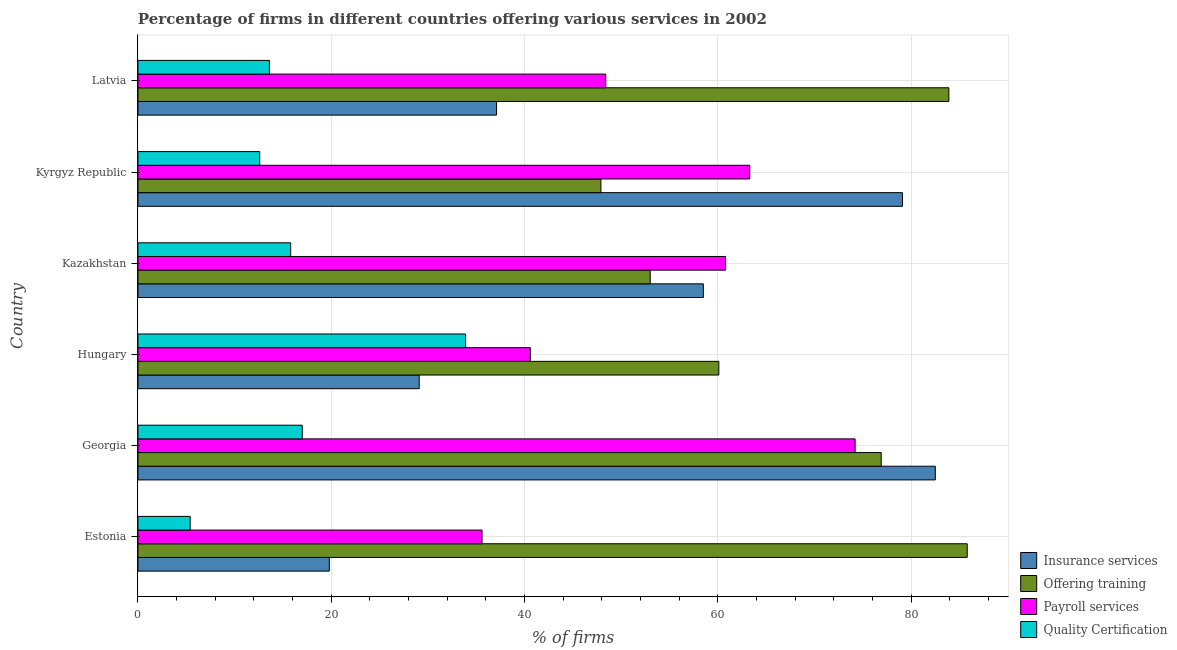How many bars are there on the 2nd tick from the bottom?
Ensure brevity in your answer.  4. What is the label of the 1st group of bars from the top?
Your answer should be compact. Latvia. What is the percentage of firms offering quality certification in Kyrgyz Republic?
Provide a succinct answer. 12.6. Across all countries, what is the maximum percentage of firms offering training?
Ensure brevity in your answer.  85.8. In which country was the percentage of firms offering payroll services maximum?
Keep it short and to the point. Georgia. In which country was the percentage of firms offering payroll services minimum?
Offer a very short reply. Estonia. What is the total percentage of firms offering training in the graph?
Keep it short and to the point. 407.6. What is the difference between the percentage of firms offering payroll services in Georgia and that in Latvia?
Keep it short and to the point. 25.8. What is the difference between the percentage of firms offering training in Hungary and the percentage of firms offering quality certification in Kazakhstan?
Provide a succinct answer. 44.3. What is the average percentage of firms offering payroll services per country?
Provide a succinct answer. 53.82. What is the ratio of the percentage of firms offering payroll services in Hungary to that in Latvia?
Make the answer very short. 0.84. Is the percentage of firms offering quality certification in Georgia less than that in Kazakhstan?
Provide a succinct answer. No. Is the difference between the percentage of firms offering quality certification in Estonia and Kyrgyz Republic greater than the difference between the percentage of firms offering training in Estonia and Kyrgyz Republic?
Your answer should be very brief. No. What is the difference between the highest and the lowest percentage of firms offering payroll services?
Offer a very short reply. 38.6. In how many countries, is the percentage of firms offering insurance services greater than the average percentage of firms offering insurance services taken over all countries?
Your answer should be compact. 3. Is the sum of the percentage of firms offering quality certification in Georgia and Hungary greater than the maximum percentage of firms offering training across all countries?
Make the answer very short. No. What does the 1st bar from the top in Kazakhstan represents?
Your answer should be very brief. Quality Certification. What does the 2nd bar from the bottom in Hungary represents?
Offer a very short reply. Offering training. How many bars are there?
Your answer should be very brief. 24. Are all the bars in the graph horizontal?
Your response must be concise. Yes. Are the values on the major ticks of X-axis written in scientific E-notation?
Offer a very short reply. No. Does the graph contain any zero values?
Your answer should be very brief. No. Does the graph contain grids?
Offer a terse response. Yes. What is the title of the graph?
Offer a terse response. Percentage of firms in different countries offering various services in 2002. Does "Debt policy" appear as one of the legend labels in the graph?
Offer a terse response. No. What is the label or title of the X-axis?
Give a very brief answer. % of firms. What is the % of firms in Insurance services in Estonia?
Provide a short and direct response. 19.8. What is the % of firms in Offering training in Estonia?
Offer a terse response. 85.8. What is the % of firms in Payroll services in Estonia?
Provide a succinct answer. 35.6. What is the % of firms in Insurance services in Georgia?
Give a very brief answer. 82.5. What is the % of firms of Offering training in Georgia?
Your response must be concise. 76.9. What is the % of firms of Payroll services in Georgia?
Offer a terse response. 74.2. What is the % of firms in Insurance services in Hungary?
Ensure brevity in your answer.  29.1. What is the % of firms of Offering training in Hungary?
Offer a very short reply. 60.1. What is the % of firms in Payroll services in Hungary?
Ensure brevity in your answer.  40.6. What is the % of firms in Quality Certification in Hungary?
Offer a very short reply. 33.9. What is the % of firms in Insurance services in Kazakhstan?
Your answer should be compact. 58.5. What is the % of firms in Offering training in Kazakhstan?
Your response must be concise. 53. What is the % of firms in Payroll services in Kazakhstan?
Your answer should be compact. 60.8. What is the % of firms in Insurance services in Kyrgyz Republic?
Ensure brevity in your answer.  79.1. What is the % of firms in Offering training in Kyrgyz Republic?
Offer a terse response. 47.9. What is the % of firms of Payroll services in Kyrgyz Republic?
Your answer should be compact. 63.3. What is the % of firms in Quality Certification in Kyrgyz Republic?
Provide a short and direct response. 12.6. What is the % of firms of Insurance services in Latvia?
Your response must be concise. 37.1. What is the % of firms in Offering training in Latvia?
Your response must be concise. 83.9. What is the % of firms of Payroll services in Latvia?
Give a very brief answer. 48.4. What is the % of firms of Quality Certification in Latvia?
Give a very brief answer. 13.6. Across all countries, what is the maximum % of firms of Insurance services?
Your response must be concise. 82.5. Across all countries, what is the maximum % of firms of Offering training?
Provide a short and direct response. 85.8. Across all countries, what is the maximum % of firms in Payroll services?
Provide a short and direct response. 74.2. Across all countries, what is the maximum % of firms of Quality Certification?
Provide a succinct answer. 33.9. Across all countries, what is the minimum % of firms in Insurance services?
Provide a succinct answer. 19.8. Across all countries, what is the minimum % of firms of Offering training?
Your answer should be very brief. 47.9. Across all countries, what is the minimum % of firms in Payroll services?
Offer a terse response. 35.6. What is the total % of firms in Insurance services in the graph?
Provide a short and direct response. 306.1. What is the total % of firms of Offering training in the graph?
Make the answer very short. 407.6. What is the total % of firms in Payroll services in the graph?
Provide a succinct answer. 322.9. What is the total % of firms of Quality Certification in the graph?
Give a very brief answer. 98.3. What is the difference between the % of firms of Insurance services in Estonia and that in Georgia?
Make the answer very short. -62.7. What is the difference between the % of firms in Payroll services in Estonia and that in Georgia?
Give a very brief answer. -38.6. What is the difference between the % of firms of Quality Certification in Estonia and that in Georgia?
Offer a terse response. -11.6. What is the difference between the % of firms in Offering training in Estonia and that in Hungary?
Provide a succinct answer. 25.7. What is the difference between the % of firms in Payroll services in Estonia and that in Hungary?
Provide a succinct answer. -5. What is the difference between the % of firms in Quality Certification in Estonia and that in Hungary?
Make the answer very short. -28.5. What is the difference between the % of firms of Insurance services in Estonia and that in Kazakhstan?
Provide a succinct answer. -38.7. What is the difference between the % of firms in Offering training in Estonia and that in Kazakhstan?
Your response must be concise. 32.8. What is the difference between the % of firms of Payroll services in Estonia and that in Kazakhstan?
Provide a short and direct response. -25.2. What is the difference between the % of firms of Quality Certification in Estonia and that in Kazakhstan?
Your answer should be very brief. -10.4. What is the difference between the % of firms of Insurance services in Estonia and that in Kyrgyz Republic?
Offer a terse response. -59.3. What is the difference between the % of firms in Offering training in Estonia and that in Kyrgyz Republic?
Make the answer very short. 37.9. What is the difference between the % of firms in Payroll services in Estonia and that in Kyrgyz Republic?
Provide a succinct answer. -27.7. What is the difference between the % of firms in Quality Certification in Estonia and that in Kyrgyz Republic?
Ensure brevity in your answer.  -7.2. What is the difference between the % of firms in Insurance services in Estonia and that in Latvia?
Give a very brief answer. -17.3. What is the difference between the % of firms of Payroll services in Estonia and that in Latvia?
Make the answer very short. -12.8. What is the difference between the % of firms of Quality Certification in Estonia and that in Latvia?
Your answer should be compact. -8.2. What is the difference between the % of firms of Insurance services in Georgia and that in Hungary?
Your answer should be compact. 53.4. What is the difference between the % of firms in Offering training in Georgia and that in Hungary?
Your response must be concise. 16.8. What is the difference between the % of firms of Payroll services in Georgia and that in Hungary?
Your answer should be compact. 33.6. What is the difference between the % of firms in Quality Certification in Georgia and that in Hungary?
Your answer should be compact. -16.9. What is the difference between the % of firms in Insurance services in Georgia and that in Kazakhstan?
Offer a terse response. 24. What is the difference between the % of firms in Offering training in Georgia and that in Kazakhstan?
Provide a succinct answer. 23.9. What is the difference between the % of firms of Insurance services in Georgia and that in Kyrgyz Republic?
Your answer should be very brief. 3.4. What is the difference between the % of firms of Offering training in Georgia and that in Kyrgyz Republic?
Give a very brief answer. 29. What is the difference between the % of firms in Payroll services in Georgia and that in Kyrgyz Republic?
Offer a terse response. 10.9. What is the difference between the % of firms in Quality Certification in Georgia and that in Kyrgyz Republic?
Make the answer very short. 4.4. What is the difference between the % of firms in Insurance services in Georgia and that in Latvia?
Give a very brief answer. 45.4. What is the difference between the % of firms in Payroll services in Georgia and that in Latvia?
Your answer should be compact. 25.8. What is the difference between the % of firms in Insurance services in Hungary and that in Kazakhstan?
Offer a very short reply. -29.4. What is the difference between the % of firms in Payroll services in Hungary and that in Kazakhstan?
Your response must be concise. -20.2. What is the difference between the % of firms in Offering training in Hungary and that in Kyrgyz Republic?
Ensure brevity in your answer.  12.2. What is the difference between the % of firms in Payroll services in Hungary and that in Kyrgyz Republic?
Your answer should be very brief. -22.7. What is the difference between the % of firms of Quality Certification in Hungary and that in Kyrgyz Republic?
Provide a short and direct response. 21.3. What is the difference between the % of firms of Insurance services in Hungary and that in Latvia?
Offer a very short reply. -8. What is the difference between the % of firms of Offering training in Hungary and that in Latvia?
Provide a short and direct response. -23.8. What is the difference between the % of firms of Quality Certification in Hungary and that in Latvia?
Offer a terse response. 20.3. What is the difference between the % of firms of Insurance services in Kazakhstan and that in Kyrgyz Republic?
Offer a terse response. -20.6. What is the difference between the % of firms of Payroll services in Kazakhstan and that in Kyrgyz Republic?
Your answer should be very brief. -2.5. What is the difference between the % of firms in Insurance services in Kazakhstan and that in Latvia?
Give a very brief answer. 21.4. What is the difference between the % of firms in Offering training in Kazakhstan and that in Latvia?
Offer a terse response. -30.9. What is the difference between the % of firms of Offering training in Kyrgyz Republic and that in Latvia?
Make the answer very short. -36. What is the difference between the % of firms of Payroll services in Kyrgyz Republic and that in Latvia?
Ensure brevity in your answer.  14.9. What is the difference between the % of firms in Insurance services in Estonia and the % of firms in Offering training in Georgia?
Provide a succinct answer. -57.1. What is the difference between the % of firms of Insurance services in Estonia and the % of firms of Payroll services in Georgia?
Ensure brevity in your answer.  -54.4. What is the difference between the % of firms of Insurance services in Estonia and the % of firms of Quality Certification in Georgia?
Keep it short and to the point. 2.8. What is the difference between the % of firms in Offering training in Estonia and the % of firms in Payroll services in Georgia?
Your answer should be compact. 11.6. What is the difference between the % of firms of Offering training in Estonia and the % of firms of Quality Certification in Georgia?
Make the answer very short. 68.8. What is the difference between the % of firms of Insurance services in Estonia and the % of firms of Offering training in Hungary?
Offer a terse response. -40.3. What is the difference between the % of firms in Insurance services in Estonia and the % of firms in Payroll services in Hungary?
Offer a very short reply. -20.8. What is the difference between the % of firms of Insurance services in Estonia and the % of firms of Quality Certification in Hungary?
Offer a very short reply. -14.1. What is the difference between the % of firms of Offering training in Estonia and the % of firms of Payroll services in Hungary?
Make the answer very short. 45.2. What is the difference between the % of firms of Offering training in Estonia and the % of firms of Quality Certification in Hungary?
Offer a terse response. 51.9. What is the difference between the % of firms in Insurance services in Estonia and the % of firms in Offering training in Kazakhstan?
Ensure brevity in your answer.  -33.2. What is the difference between the % of firms of Insurance services in Estonia and the % of firms of Payroll services in Kazakhstan?
Offer a very short reply. -41. What is the difference between the % of firms of Insurance services in Estonia and the % of firms of Quality Certification in Kazakhstan?
Provide a succinct answer. 4. What is the difference between the % of firms in Offering training in Estonia and the % of firms in Payroll services in Kazakhstan?
Your response must be concise. 25. What is the difference between the % of firms in Payroll services in Estonia and the % of firms in Quality Certification in Kazakhstan?
Make the answer very short. 19.8. What is the difference between the % of firms in Insurance services in Estonia and the % of firms in Offering training in Kyrgyz Republic?
Your answer should be compact. -28.1. What is the difference between the % of firms in Insurance services in Estonia and the % of firms in Payroll services in Kyrgyz Republic?
Your answer should be compact. -43.5. What is the difference between the % of firms in Offering training in Estonia and the % of firms in Payroll services in Kyrgyz Republic?
Your response must be concise. 22.5. What is the difference between the % of firms of Offering training in Estonia and the % of firms of Quality Certification in Kyrgyz Republic?
Your answer should be very brief. 73.2. What is the difference between the % of firms in Insurance services in Estonia and the % of firms in Offering training in Latvia?
Keep it short and to the point. -64.1. What is the difference between the % of firms of Insurance services in Estonia and the % of firms of Payroll services in Latvia?
Offer a very short reply. -28.6. What is the difference between the % of firms of Insurance services in Estonia and the % of firms of Quality Certification in Latvia?
Give a very brief answer. 6.2. What is the difference between the % of firms in Offering training in Estonia and the % of firms in Payroll services in Latvia?
Give a very brief answer. 37.4. What is the difference between the % of firms in Offering training in Estonia and the % of firms in Quality Certification in Latvia?
Your answer should be very brief. 72.2. What is the difference between the % of firms in Payroll services in Estonia and the % of firms in Quality Certification in Latvia?
Give a very brief answer. 22. What is the difference between the % of firms in Insurance services in Georgia and the % of firms in Offering training in Hungary?
Your answer should be compact. 22.4. What is the difference between the % of firms of Insurance services in Georgia and the % of firms of Payroll services in Hungary?
Make the answer very short. 41.9. What is the difference between the % of firms in Insurance services in Georgia and the % of firms in Quality Certification in Hungary?
Provide a succinct answer. 48.6. What is the difference between the % of firms in Offering training in Georgia and the % of firms in Payroll services in Hungary?
Offer a very short reply. 36.3. What is the difference between the % of firms in Payroll services in Georgia and the % of firms in Quality Certification in Hungary?
Give a very brief answer. 40.3. What is the difference between the % of firms in Insurance services in Georgia and the % of firms in Offering training in Kazakhstan?
Give a very brief answer. 29.5. What is the difference between the % of firms in Insurance services in Georgia and the % of firms in Payroll services in Kazakhstan?
Ensure brevity in your answer.  21.7. What is the difference between the % of firms of Insurance services in Georgia and the % of firms of Quality Certification in Kazakhstan?
Keep it short and to the point. 66.7. What is the difference between the % of firms in Offering training in Georgia and the % of firms in Quality Certification in Kazakhstan?
Your answer should be compact. 61.1. What is the difference between the % of firms of Payroll services in Georgia and the % of firms of Quality Certification in Kazakhstan?
Offer a terse response. 58.4. What is the difference between the % of firms of Insurance services in Georgia and the % of firms of Offering training in Kyrgyz Republic?
Provide a succinct answer. 34.6. What is the difference between the % of firms of Insurance services in Georgia and the % of firms of Payroll services in Kyrgyz Republic?
Your answer should be compact. 19.2. What is the difference between the % of firms in Insurance services in Georgia and the % of firms in Quality Certification in Kyrgyz Republic?
Keep it short and to the point. 69.9. What is the difference between the % of firms in Offering training in Georgia and the % of firms in Payroll services in Kyrgyz Republic?
Your answer should be compact. 13.6. What is the difference between the % of firms of Offering training in Georgia and the % of firms of Quality Certification in Kyrgyz Republic?
Your answer should be compact. 64.3. What is the difference between the % of firms in Payroll services in Georgia and the % of firms in Quality Certification in Kyrgyz Republic?
Ensure brevity in your answer.  61.6. What is the difference between the % of firms in Insurance services in Georgia and the % of firms in Payroll services in Latvia?
Your answer should be very brief. 34.1. What is the difference between the % of firms of Insurance services in Georgia and the % of firms of Quality Certification in Latvia?
Provide a short and direct response. 68.9. What is the difference between the % of firms in Offering training in Georgia and the % of firms in Quality Certification in Latvia?
Your answer should be compact. 63.3. What is the difference between the % of firms in Payroll services in Georgia and the % of firms in Quality Certification in Latvia?
Give a very brief answer. 60.6. What is the difference between the % of firms of Insurance services in Hungary and the % of firms of Offering training in Kazakhstan?
Keep it short and to the point. -23.9. What is the difference between the % of firms in Insurance services in Hungary and the % of firms in Payroll services in Kazakhstan?
Provide a short and direct response. -31.7. What is the difference between the % of firms in Insurance services in Hungary and the % of firms in Quality Certification in Kazakhstan?
Keep it short and to the point. 13.3. What is the difference between the % of firms in Offering training in Hungary and the % of firms in Quality Certification in Kazakhstan?
Ensure brevity in your answer.  44.3. What is the difference between the % of firms in Payroll services in Hungary and the % of firms in Quality Certification in Kazakhstan?
Offer a very short reply. 24.8. What is the difference between the % of firms of Insurance services in Hungary and the % of firms of Offering training in Kyrgyz Republic?
Your answer should be very brief. -18.8. What is the difference between the % of firms of Insurance services in Hungary and the % of firms of Payroll services in Kyrgyz Republic?
Make the answer very short. -34.2. What is the difference between the % of firms in Offering training in Hungary and the % of firms in Quality Certification in Kyrgyz Republic?
Ensure brevity in your answer.  47.5. What is the difference between the % of firms of Insurance services in Hungary and the % of firms of Offering training in Latvia?
Your response must be concise. -54.8. What is the difference between the % of firms of Insurance services in Hungary and the % of firms of Payroll services in Latvia?
Give a very brief answer. -19.3. What is the difference between the % of firms in Offering training in Hungary and the % of firms in Quality Certification in Latvia?
Offer a terse response. 46.5. What is the difference between the % of firms in Payroll services in Hungary and the % of firms in Quality Certification in Latvia?
Your response must be concise. 27. What is the difference between the % of firms of Insurance services in Kazakhstan and the % of firms of Offering training in Kyrgyz Republic?
Provide a succinct answer. 10.6. What is the difference between the % of firms of Insurance services in Kazakhstan and the % of firms of Quality Certification in Kyrgyz Republic?
Your answer should be compact. 45.9. What is the difference between the % of firms in Offering training in Kazakhstan and the % of firms in Payroll services in Kyrgyz Republic?
Your response must be concise. -10.3. What is the difference between the % of firms in Offering training in Kazakhstan and the % of firms in Quality Certification in Kyrgyz Republic?
Provide a short and direct response. 40.4. What is the difference between the % of firms in Payroll services in Kazakhstan and the % of firms in Quality Certification in Kyrgyz Republic?
Give a very brief answer. 48.2. What is the difference between the % of firms of Insurance services in Kazakhstan and the % of firms of Offering training in Latvia?
Your response must be concise. -25.4. What is the difference between the % of firms of Insurance services in Kazakhstan and the % of firms of Payroll services in Latvia?
Offer a very short reply. 10.1. What is the difference between the % of firms of Insurance services in Kazakhstan and the % of firms of Quality Certification in Latvia?
Your answer should be compact. 44.9. What is the difference between the % of firms of Offering training in Kazakhstan and the % of firms of Quality Certification in Latvia?
Your answer should be very brief. 39.4. What is the difference between the % of firms in Payroll services in Kazakhstan and the % of firms in Quality Certification in Latvia?
Ensure brevity in your answer.  47.2. What is the difference between the % of firms of Insurance services in Kyrgyz Republic and the % of firms of Payroll services in Latvia?
Provide a short and direct response. 30.7. What is the difference between the % of firms of Insurance services in Kyrgyz Republic and the % of firms of Quality Certification in Latvia?
Your response must be concise. 65.5. What is the difference between the % of firms in Offering training in Kyrgyz Republic and the % of firms in Quality Certification in Latvia?
Provide a succinct answer. 34.3. What is the difference between the % of firms in Payroll services in Kyrgyz Republic and the % of firms in Quality Certification in Latvia?
Keep it short and to the point. 49.7. What is the average % of firms of Insurance services per country?
Provide a succinct answer. 51.02. What is the average % of firms in Offering training per country?
Offer a terse response. 67.93. What is the average % of firms in Payroll services per country?
Provide a succinct answer. 53.82. What is the average % of firms of Quality Certification per country?
Keep it short and to the point. 16.38. What is the difference between the % of firms in Insurance services and % of firms in Offering training in Estonia?
Make the answer very short. -66. What is the difference between the % of firms of Insurance services and % of firms of Payroll services in Estonia?
Keep it short and to the point. -15.8. What is the difference between the % of firms of Offering training and % of firms of Payroll services in Estonia?
Offer a very short reply. 50.2. What is the difference between the % of firms in Offering training and % of firms in Quality Certification in Estonia?
Your answer should be compact. 80.4. What is the difference between the % of firms of Payroll services and % of firms of Quality Certification in Estonia?
Provide a succinct answer. 30.2. What is the difference between the % of firms of Insurance services and % of firms of Offering training in Georgia?
Give a very brief answer. 5.6. What is the difference between the % of firms of Insurance services and % of firms of Payroll services in Georgia?
Offer a very short reply. 8.3. What is the difference between the % of firms in Insurance services and % of firms in Quality Certification in Georgia?
Your answer should be compact. 65.5. What is the difference between the % of firms in Offering training and % of firms in Quality Certification in Georgia?
Give a very brief answer. 59.9. What is the difference between the % of firms of Payroll services and % of firms of Quality Certification in Georgia?
Make the answer very short. 57.2. What is the difference between the % of firms of Insurance services and % of firms of Offering training in Hungary?
Offer a terse response. -31. What is the difference between the % of firms of Insurance services and % of firms of Payroll services in Hungary?
Keep it short and to the point. -11.5. What is the difference between the % of firms of Insurance services and % of firms of Quality Certification in Hungary?
Provide a short and direct response. -4.8. What is the difference between the % of firms of Offering training and % of firms of Payroll services in Hungary?
Your answer should be very brief. 19.5. What is the difference between the % of firms in Offering training and % of firms in Quality Certification in Hungary?
Give a very brief answer. 26.2. What is the difference between the % of firms of Insurance services and % of firms of Offering training in Kazakhstan?
Provide a short and direct response. 5.5. What is the difference between the % of firms of Insurance services and % of firms of Payroll services in Kazakhstan?
Make the answer very short. -2.3. What is the difference between the % of firms of Insurance services and % of firms of Quality Certification in Kazakhstan?
Provide a short and direct response. 42.7. What is the difference between the % of firms of Offering training and % of firms of Payroll services in Kazakhstan?
Give a very brief answer. -7.8. What is the difference between the % of firms of Offering training and % of firms of Quality Certification in Kazakhstan?
Provide a short and direct response. 37.2. What is the difference between the % of firms in Payroll services and % of firms in Quality Certification in Kazakhstan?
Offer a terse response. 45. What is the difference between the % of firms in Insurance services and % of firms in Offering training in Kyrgyz Republic?
Your response must be concise. 31.2. What is the difference between the % of firms in Insurance services and % of firms in Payroll services in Kyrgyz Republic?
Offer a terse response. 15.8. What is the difference between the % of firms of Insurance services and % of firms of Quality Certification in Kyrgyz Republic?
Your answer should be very brief. 66.5. What is the difference between the % of firms in Offering training and % of firms in Payroll services in Kyrgyz Republic?
Give a very brief answer. -15.4. What is the difference between the % of firms in Offering training and % of firms in Quality Certification in Kyrgyz Republic?
Your answer should be compact. 35.3. What is the difference between the % of firms in Payroll services and % of firms in Quality Certification in Kyrgyz Republic?
Give a very brief answer. 50.7. What is the difference between the % of firms in Insurance services and % of firms in Offering training in Latvia?
Give a very brief answer. -46.8. What is the difference between the % of firms of Offering training and % of firms of Payroll services in Latvia?
Your response must be concise. 35.5. What is the difference between the % of firms in Offering training and % of firms in Quality Certification in Latvia?
Make the answer very short. 70.3. What is the difference between the % of firms of Payroll services and % of firms of Quality Certification in Latvia?
Your answer should be compact. 34.8. What is the ratio of the % of firms in Insurance services in Estonia to that in Georgia?
Provide a succinct answer. 0.24. What is the ratio of the % of firms in Offering training in Estonia to that in Georgia?
Keep it short and to the point. 1.12. What is the ratio of the % of firms in Payroll services in Estonia to that in Georgia?
Provide a short and direct response. 0.48. What is the ratio of the % of firms of Quality Certification in Estonia to that in Georgia?
Your response must be concise. 0.32. What is the ratio of the % of firms of Insurance services in Estonia to that in Hungary?
Offer a very short reply. 0.68. What is the ratio of the % of firms of Offering training in Estonia to that in Hungary?
Offer a terse response. 1.43. What is the ratio of the % of firms of Payroll services in Estonia to that in Hungary?
Make the answer very short. 0.88. What is the ratio of the % of firms in Quality Certification in Estonia to that in Hungary?
Provide a short and direct response. 0.16. What is the ratio of the % of firms of Insurance services in Estonia to that in Kazakhstan?
Your answer should be very brief. 0.34. What is the ratio of the % of firms in Offering training in Estonia to that in Kazakhstan?
Give a very brief answer. 1.62. What is the ratio of the % of firms in Payroll services in Estonia to that in Kazakhstan?
Provide a short and direct response. 0.59. What is the ratio of the % of firms of Quality Certification in Estonia to that in Kazakhstan?
Ensure brevity in your answer.  0.34. What is the ratio of the % of firms in Insurance services in Estonia to that in Kyrgyz Republic?
Provide a short and direct response. 0.25. What is the ratio of the % of firms of Offering training in Estonia to that in Kyrgyz Republic?
Your answer should be very brief. 1.79. What is the ratio of the % of firms of Payroll services in Estonia to that in Kyrgyz Republic?
Provide a short and direct response. 0.56. What is the ratio of the % of firms in Quality Certification in Estonia to that in Kyrgyz Republic?
Provide a succinct answer. 0.43. What is the ratio of the % of firms of Insurance services in Estonia to that in Latvia?
Offer a terse response. 0.53. What is the ratio of the % of firms of Offering training in Estonia to that in Latvia?
Ensure brevity in your answer.  1.02. What is the ratio of the % of firms in Payroll services in Estonia to that in Latvia?
Make the answer very short. 0.74. What is the ratio of the % of firms of Quality Certification in Estonia to that in Latvia?
Give a very brief answer. 0.4. What is the ratio of the % of firms in Insurance services in Georgia to that in Hungary?
Your answer should be compact. 2.84. What is the ratio of the % of firms in Offering training in Georgia to that in Hungary?
Ensure brevity in your answer.  1.28. What is the ratio of the % of firms of Payroll services in Georgia to that in Hungary?
Provide a short and direct response. 1.83. What is the ratio of the % of firms in Quality Certification in Georgia to that in Hungary?
Your answer should be very brief. 0.5. What is the ratio of the % of firms in Insurance services in Georgia to that in Kazakhstan?
Provide a short and direct response. 1.41. What is the ratio of the % of firms in Offering training in Georgia to that in Kazakhstan?
Keep it short and to the point. 1.45. What is the ratio of the % of firms of Payroll services in Georgia to that in Kazakhstan?
Ensure brevity in your answer.  1.22. What is the ratio of the % of firms of Quality Certification in Georgia to that in Kazakhstan?
Ensure brevity in your answer.  1.08. What is the ratio of the % of firms in Insurance services in Georgia to that in Kyrgyz Republic?
Your answer should be compact. 1.04. What is the ratio of the % of firms in Offering training in Georgia to that in Kyrgyz Republic?
Provide a short and direct response. 1.61. What is the ratio of the % of firms in Payroll services in Georgia to that in Kyrgyz Republic?
Ensure brevity in your answer.  1.17. What is the ratio of the % of firms in Quality Certification in Georgia to that in Kyrgyz Republic?
Keep it short and to the point. 1.35. What is the ratio of the % of firms of Insurance services in Georgia to that in Latvia?
Keep it short and to the point. 2.22. What is the ratio of the % of firms in Offering training in Georgia to that in Latvia?
Your answer should be compact. 0.92. What is the ratio of the % of firms of Payroll services in Georgia to that in Latvia?
Provide a succinct answer. 1.53. What is the ratio of the % of firms in Insurance services in Hungary to that in Kazakhstan?
Your answer should be compact. 0.5. What is the ratio of the % of firms in Offering training in Hungary to that in Kazakhstan?
Provide a succinct answer. 1.13. What is the ratio of the % of firms of Payroll services in Hungary to that in Kazakhstan?
Keep it short and to the point. 0.67. What is the ratio of the % of firms in Quality Certification in Hungary to that in Kazakhstan?
Provide a short and direct response. 2.15. What is the ratio of the % of firms in Insurance services in Hungary to that in Kyrgyz Republic?
Provide a short and direct response. 0.37. What is the ratio of the % of firms of Offering training in Hungary to that in Kyrgyz Republic?
Provide a short and direct response. 1.25. What is the ratio of the % of firms of Payroll services in Hungary to that in Kyrgyz Republic?
Provide a short and direct response. 0.64. What is the ratio of the % of firms in Quality Certification in Hungary to that in Kyrgyz Republic?
Provide a short and direct response. 2.69. What is the ratio of the % of firms in Insurance services in Hungary to that in Latvia?
Ensure brevity in your answer.  0.78. What is the ratio of the % of firms of Offering training in Hungary to that in Latvia?
Your answer should be compact. 0.72. What is the ratio of the % of firms of Payroll services in Hungary to that in Latvia?
Make the answer very short. 0.84. What is the ratio of the % of firms in Quality Certification in Hungary to that in Latvia?
Offer a terse response. 2.49. What is the ratio of the % of firms of Insurance services in Kazakhstan to that in Kyrgyz Republic?
Your response must be concise. 0.74. What is the ratio of the % of firms of Offering training in Kazakhstan to that in Kyrgyz Republic?
Provide a succinct answer. 1.11. What is the ratio of the % of firms of Payroll services in Kazakhstan to that in Kyrgyz Republic?
Keep it short and to the point. 0.96. What is the ratio of the % of firms of Quality Certification in Kazakhstan to that in Kyrgyz Republic?
Offer a terse response. 1.25. What is the ratio of the % of firms in Insurance services in Kazakhstan to that in Latvia?
Make the answer very short. 1.58. What is the ratio of the % of firms of Offering training in Kazakhstan to that in Latvia?
Offer a terse response. 0.63. What is the ratio of the % of firms in Payroll services in Kazakhstan to that in Latvia?
Give a very brief answer. 1.26. What is the ratio of the % of firms in Quality Certification in Kazakhstan to that in Latvia?
Your response must be concise. 1.16. What is the ratio of the % of firms in Insurance services in Kyrgyz Republic to that in Latvia?
Ensure brevity in your answer.  2.13. What is the ratio of the % of firms in Offering training in Kyrgyz Republic to that in Latvia?
Make the answer very short. 0.57. What is the ratio of the % of firms in Payroll services in Kyrgyz Republic to that in Latvia?
Make the answer very short. 1.31. What is the ratio of the % of firms of Quality Certification in Kyrgyz Republic to that in Latvia?
Offer a very short reply. 0.93. What is the difference between the highest and the second highest % of firms of Offering training?
Your answer should be very brief. 1.9. What is the difference between the highest and the second highest % of firms in Quality Certification?
Your response must be concise. 16.9. What is the difference between the highest and the lowest % of firms of Insurance services?
Ensure brevity in your answer.  62.7. What is the difference between the highest and the lowest % of firms in Offering training?
Your answer should be compact. 37.9. What is the difference between the highest and the lowest % of firms of Payroll services?
Your answer should be very brief. 38.6. 